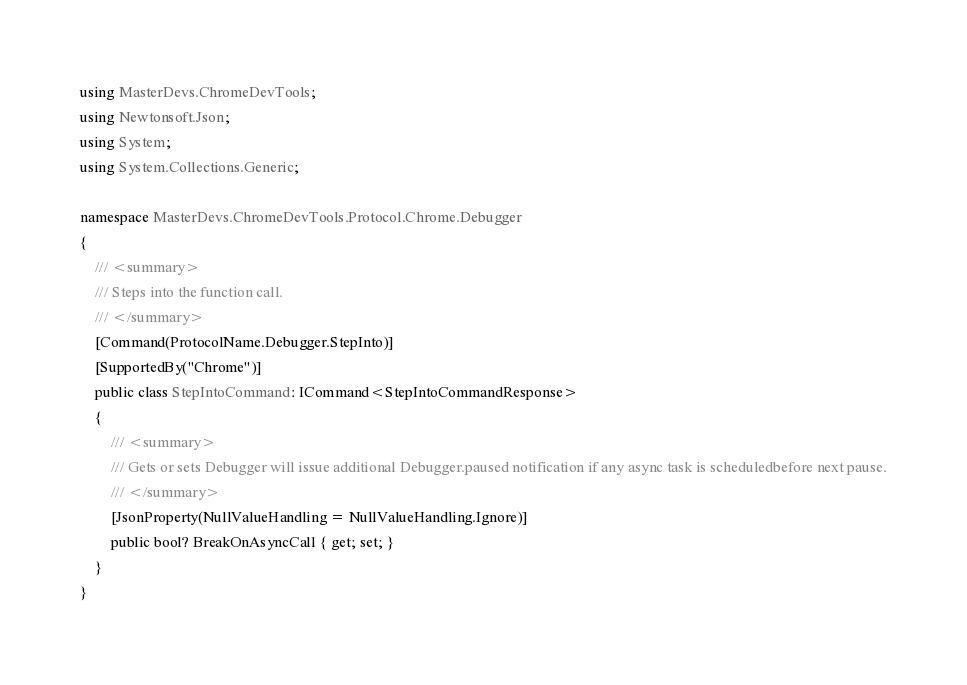Convert code to text. <code><loc_0><loc_0><loc_500><loc_500><_C#_>using MasterDevs.ChromeDevTools;
using Newtonsoft.Json;
using System;
using System.Collections.Generic;

namespace MasterDevs.ChromeDevTools.Protocol.Chrome.Debugger
{
	/// <summary>
	/// Steps into the function call.
	/// </summary>
	[Command(ProtocolName.Debugger.StepInto)]
	[SupportedBy("Chrome")]
	public class StepIntoCommand: ICommand<StepIntoCommandResponse>
	{
		/// <summary>
		/// Gets or sets Debugger will issue additional Debugger.paused notification if any async task is scheduledbefore next pause.
		/// </summary>
		[JsonProperty(NullValueHandling = NullValueHandling.Ignore)]
		public bool? BreakOnAsyncCall { get; set; }
	}
}
</code> 